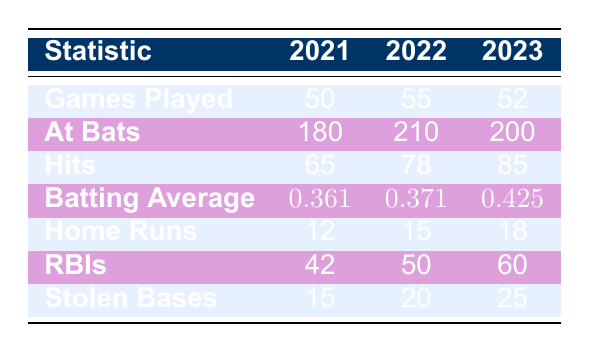What is Janae Jefferson's batting average in 2023? The table lists her batting average for each season, and for 2023, it shows a value of 0.425.
Answer: 0.425 How many home runs did Janae Jefferson hit in the 2022 season? By checking the 2022 column under home runs, we find that she hit 15 home runs that season.
Answer: 15 What was the total number of runs batted in (RBIs) for Janae Jefferson across all three seasons? To find the total RBIs, we sum the values from all three seasons: 42 (2021) + 50 (2022) + 60 (2023) = 152.
Answer: 152 Did Janae Jefferson play more games in 2021 or 2022? In the table, the games played in 2021 are 50 and in 2022 are 55. Since 55 is greater than 50, she played more games in 2022.
Answer: Yes What is the difference in stolen bases between the 2021 season and the 2023 season? The table shows 15 stolen bases in 2021 and 25 in 2023. The difference is calculated as 25 - 15 = 10.
Answer: 10 What is the average number of hits per season over the three years? To find the average number of hits, we sum the hits: 65 (2021) + 78 (2022) + 85 (2023) = 228. There are three seasons, so the average is 228 / 3 = 76.
Answer: 76 In which season did Janae Jefferson achieve her highest batting average? The batting averages listed are 0.361 for 2021, 0.371 for 2022, and 0.425 for 2023. The highest average can be found by comparing these values, and it is evident that 0.425 in 2023 is the highest.
Answer: 2023 How many total at-bats did Janae Jefferson have over the three seasons? The total at-bats are found by summing the at-bats for each season: 180 (2021) + 210 (2022) + 200 (2023) = 590.
Answer: 590 Was there an increase in Janae Jefferson's home runs from 2021 to 2023? The home runs are 12 for 2021 and 18 for 2023. Since 18 is greater than 12, this indicates an increase.
Answer: Yes 